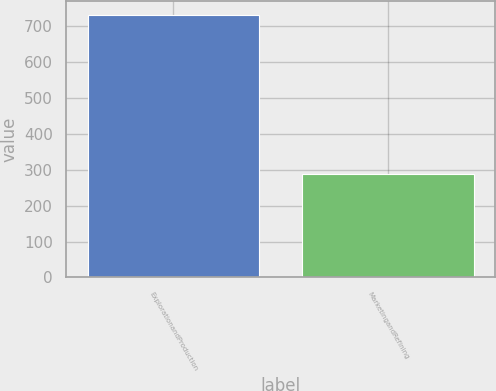<chart> <loc_0><loc_0><loc_500><loc_500><bar_chart><fcel>ExplorationandProduction<fcel>MarketingandRefining<nl><fcel>732<fcel>289<nl></chart> 